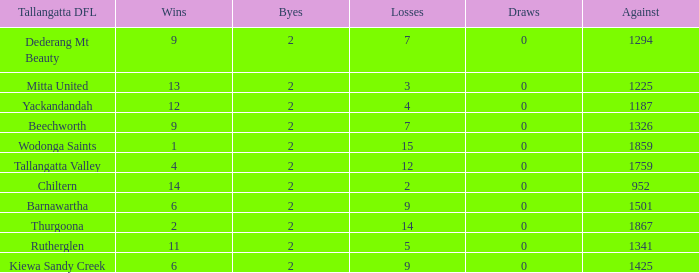What are the fewest draws with less than 7 losses and Mitta United is the Tallagatta DFL? 0.0. 